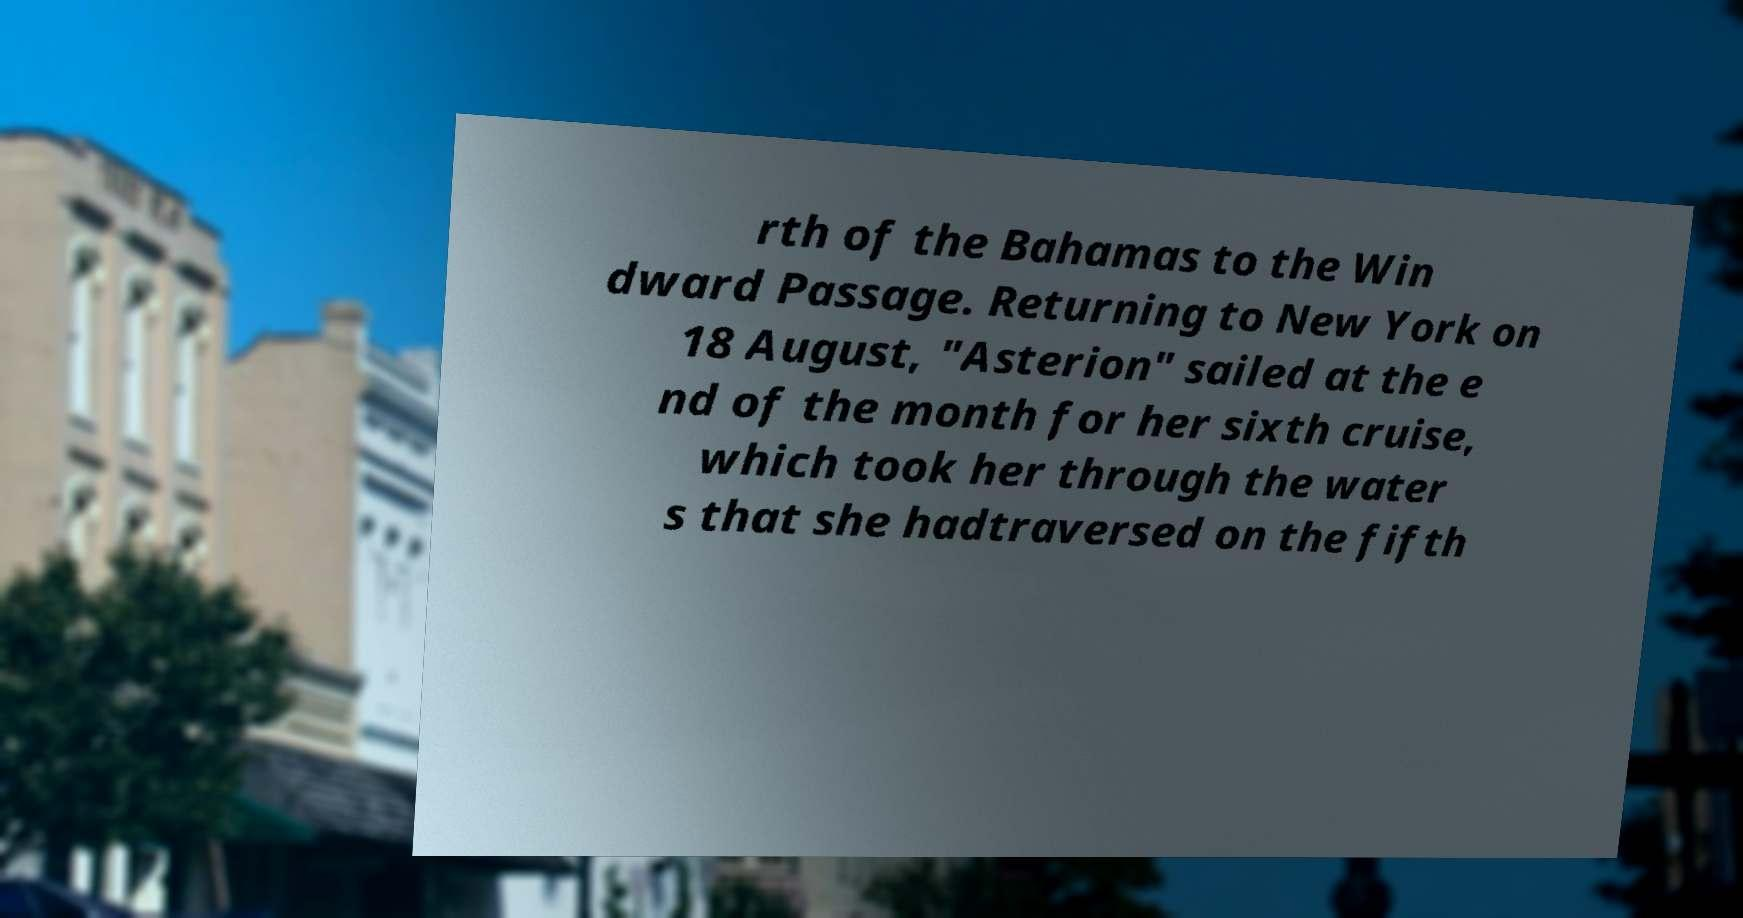What messages or text are displayed in this image? I need them in a readable, typed format. rth of the Bahamas to the Win dward Passage. Returning to New York on 18 August, "Asterion" sailed at the e nd of the month for her sixth cruise, which took her through the water s that she hadtraversed on the fifth 